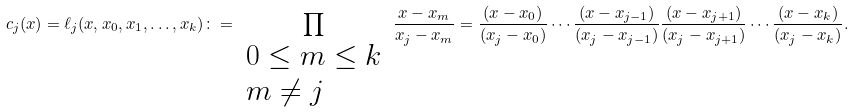Convert formula to latex. <formula><loc_0><loc_0><loc_500><loc_500>c _ { j } ( x ) = \ell _ { j } ( x , x _ { 0 } , x _ { 1 } , \dots , x _ { k } ) \colon = \prod _ { \begin{array} { l } { 0 \leq m \leq k } \\ { m \neq j } \end{array} } { \frac { x - x _ { m } } { x _ { j } - x _ { m } } } = { \frac { ( x - x _ { 0 } ) } { ( x _ { j } - x _ { 0 } ) } } \cdots { \frac { ( x - x _ { j - 1 } ) } { ( x _ { j } - x _ { j - 1 } ) } } { \frac { ( x - x _ { j + 1 } ) } { ( x _ { j } - x _ { j + 1 } ) } } \cdots { \frac { ( x - x _ { k } ) } { ( x _ { j } - x _ { k } ) } } .</formula> 